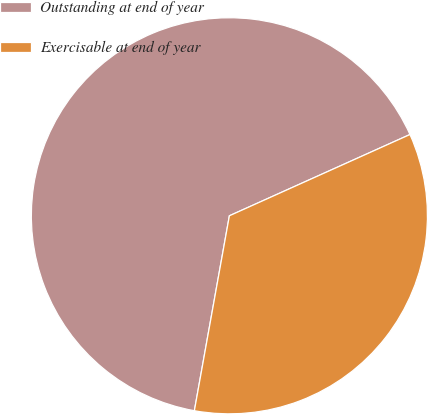Convert chart. <chart><loc_0><loc_0><loc_500><loc_500><pie_chart><fcel>Outstanding at end of year<fcel>Exercisable at end of year<nl><fcel>65.44%<fcel>34.56%<nl></chart> 